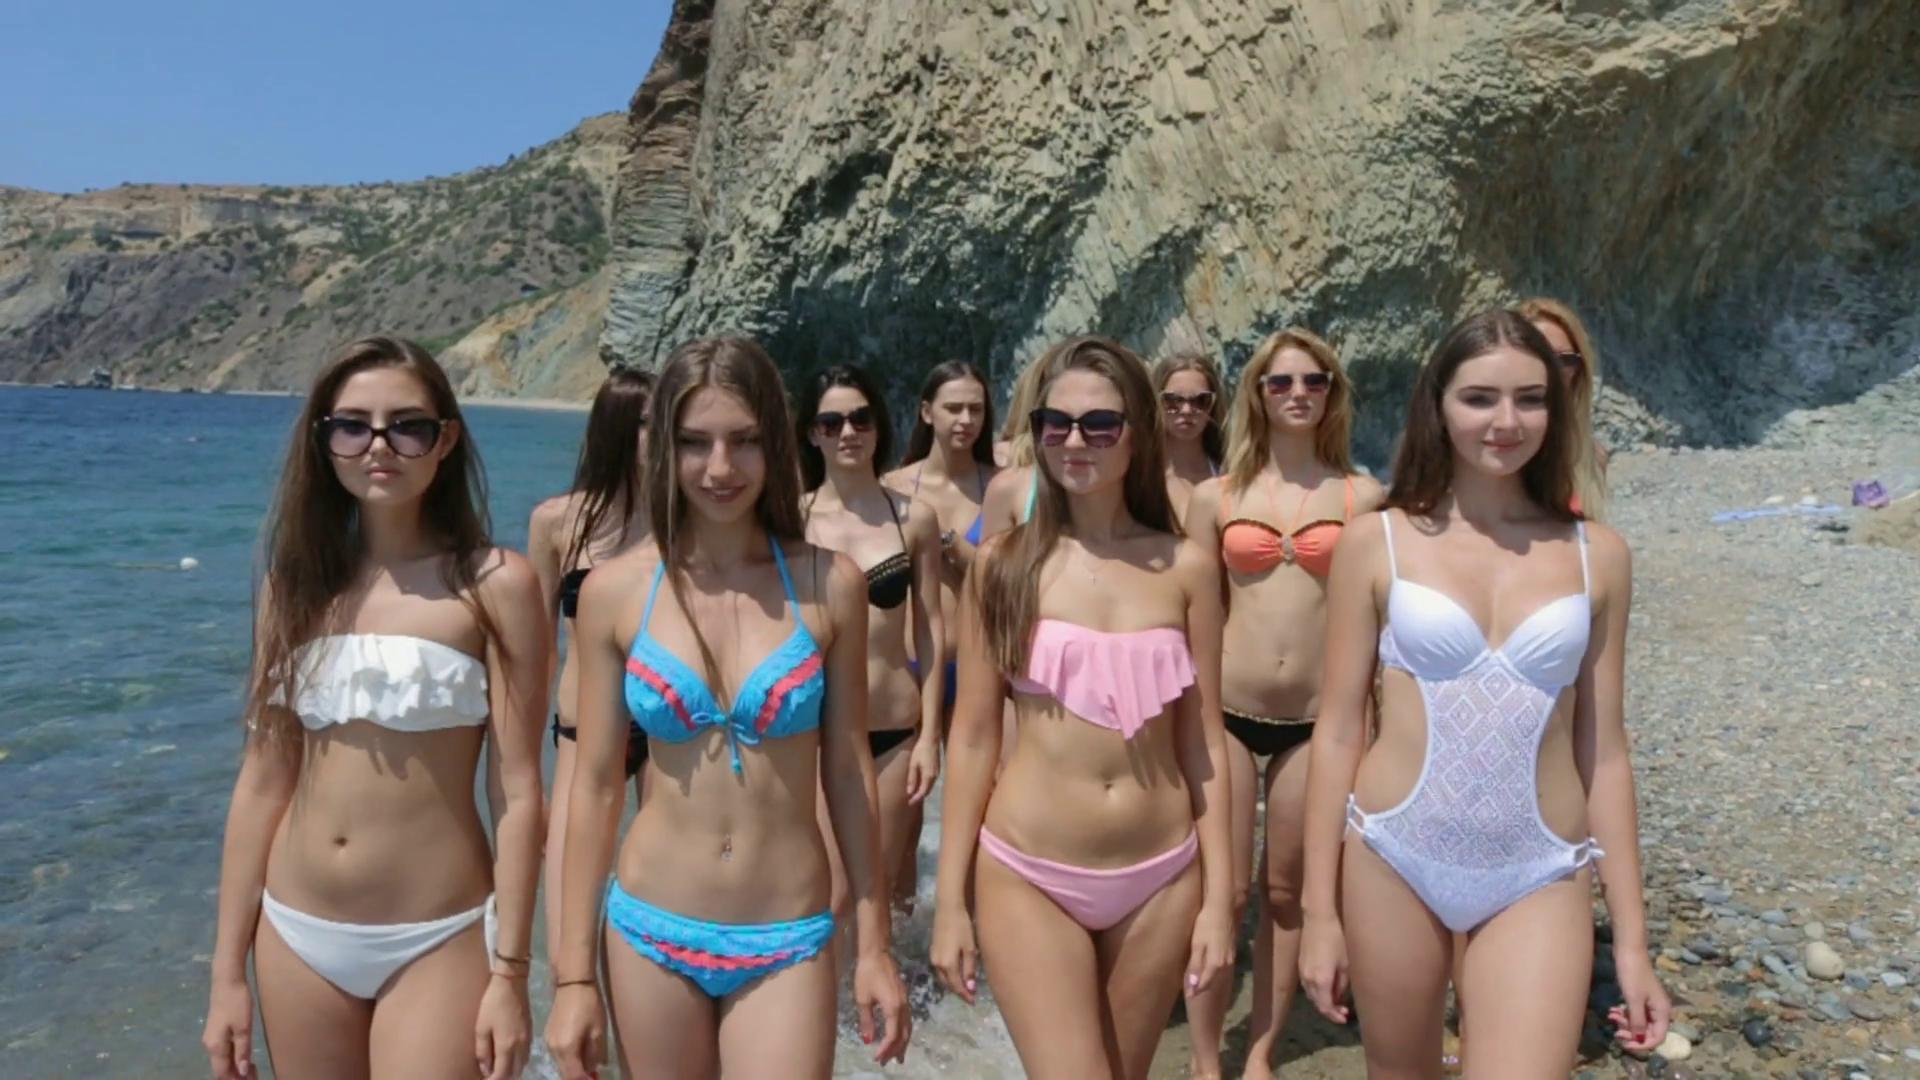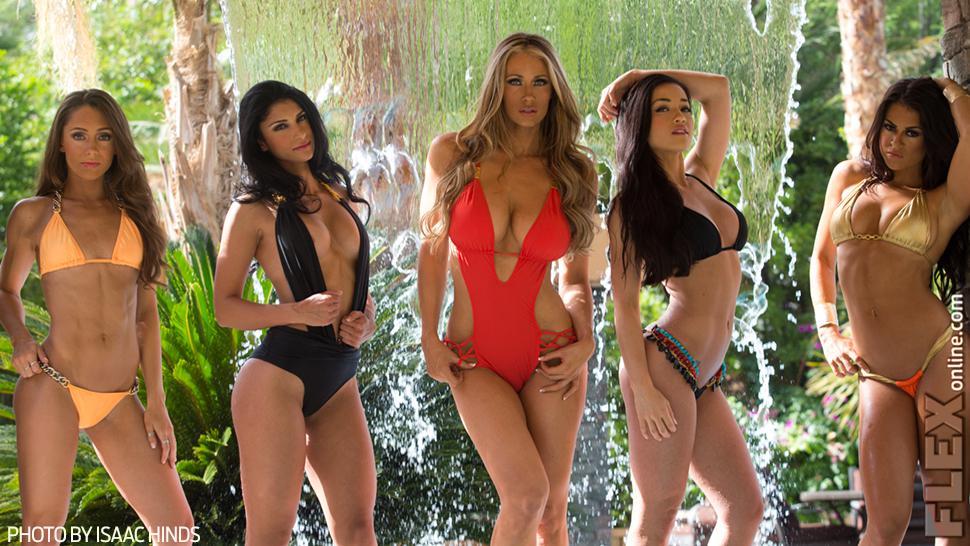The first image is the image on the left, the second image is the image on the right. Evaluate the accuracy of this statement regarding the images: "One image shows four bikini models in sunglasses standing in front of the ocean.". Is it true? Answer yes or no. No. The first image is the image on the left, the second image is the image on the right. Evaluate the accuracy of this statement regarding the images: "There are eight or less women.". Is it true? Answer yes or no. No. 